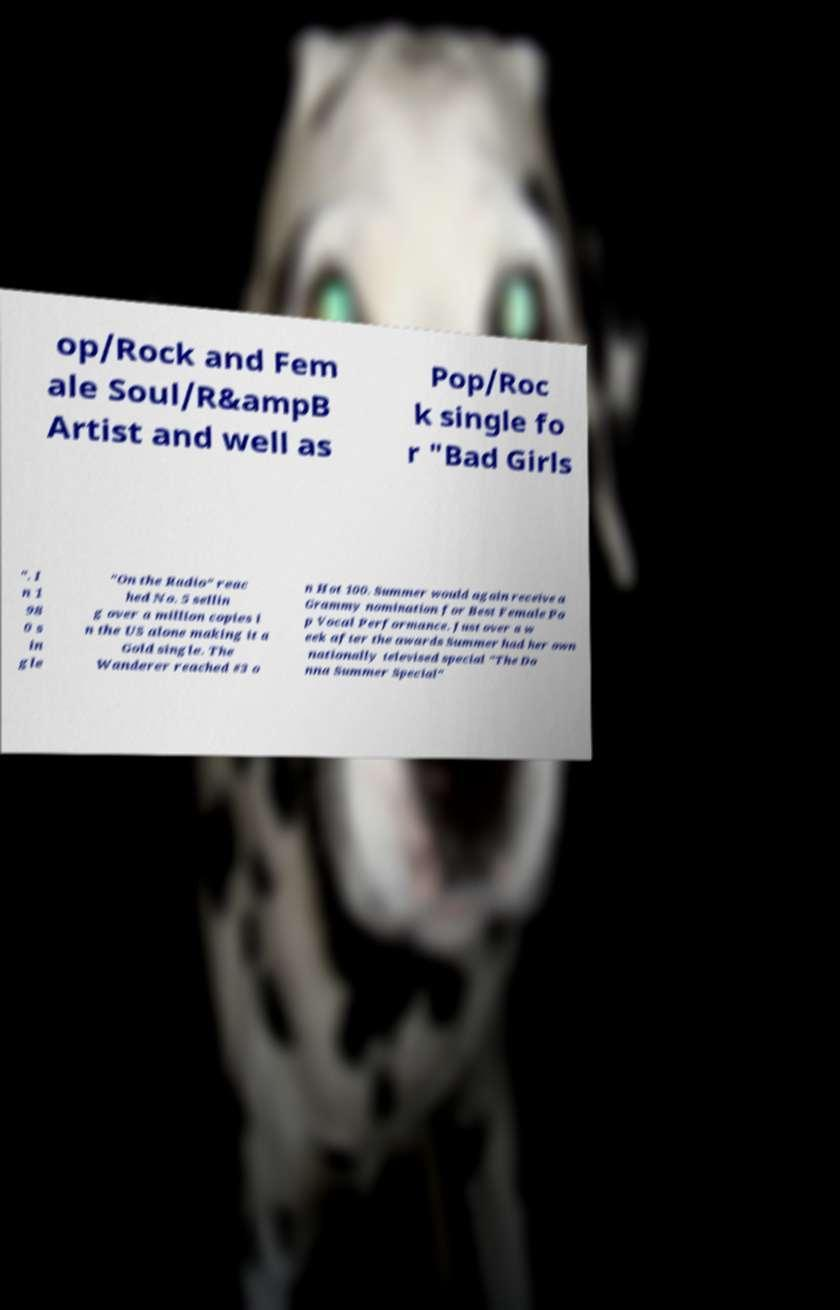For documentation purposes, I need the text within this image transcribed. Could you provide that? op/Rock and Fem ale Soul/R&ampB Artist and well as Pop/Roc k single fo r "Bad Girls ". I n 1 98 0 s in gle "On the Radio" reac hed No. 5 sellin g over a million copies i n the US alone making it a Gold single. The Wanderer reached #3 o n Hot 100. Summer would again receive a Grammy nomination for Best Female Po p Vocal Performance. Just over a w eek after the awards Summer had her own nationally televised special "The Do nna Summer Special" 